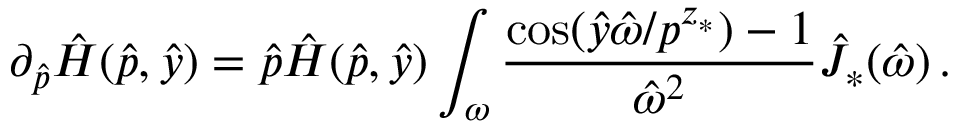<formula> <loc_0><loc_0><loc_500><loc_500>\partial _ { \hat { p } } \hat { H } ( \hat { p } , \hat { y } ) = \hat { p } \hat { H } ( \hat { p } , \hat { y } ) \int _ { \omega } \frac { \cos ( \hat { y } \hat { \omega } / p ^ { z _ { * } } ) - 1 } { \hat { \omega } ^ { 2 } } \hat { J } _ { * } ( \hat { \omega } ) \, .</formula> 